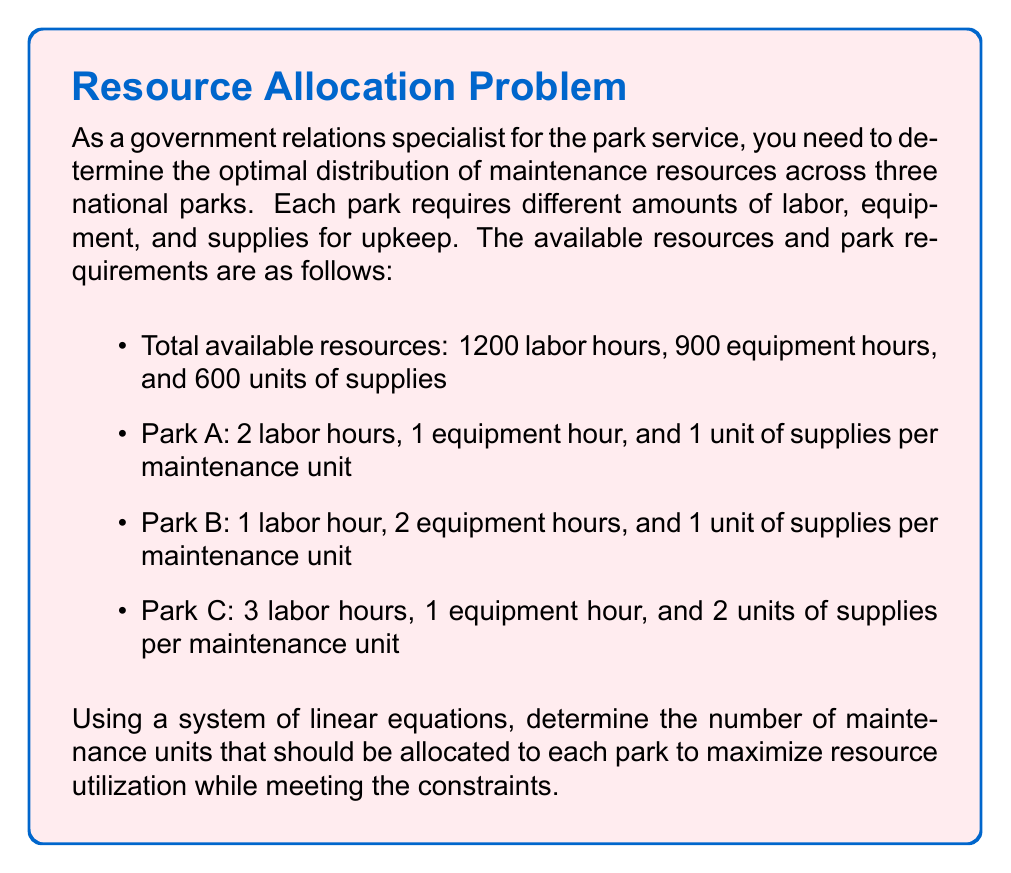Give your solution to this math problem. To solve this problem, we'll use a system of linear equations. Let's define our variables:

$x$ = number of maintenance units for Park A
$y$ = number of maintenance units for Park B
$z$ = number of maintenance units for Park C

Now, we can set up our system of equations based on the resource constraints:

1. Labor hours: $2x + y + 3z = 1200$
2. Equipment hours: $x + 2y + z = 900$
3. Supplies: $x + y + 2z = 600$

To solve this system, we'll use the elimination method:

Step 1: Multiply equation (1) by 2 and equation (2) by -3:
$4x + 2y + 6z = 2400$
$-3x - 6y - 3z = -2700$

Add these equations:
$x - 4y + 3z = -300$ (4)

Step 2: Multiply equation (2) by 2 and equation (3) by -1:
$2x + 4y + 2z = 1800$
$-x - y - 2z = -600$

Add these equations:
$x + 3y = 1200$ (5)

Step 3: Use equations (4) and (5) to solve for x and y in terms of z:
From (5): $x = 1200 - 3y$
Substitute into (4):
$(1200 - 3y) - 4y + 3z = -300$
$1200 - 7y + 3z = -300$
$-7y + 3z = -1500$
$y = \frac{1500 - 3z}{7}$

Step 4: Substitute these expressions into equation (3):
$(1200 - 3y) + (\frac{1500 - 3z}{7}) + 2z = 600$

Simplify and solve for z:
$1200 - 3(\frac{1500 - 3z}{7}) + \frac{1500 - 3z}{7} + 2z = 600$
$8400 - 4500 + 9z + 1500 - 3z + 14z = 4200$
$20z = -1200$
$z = -60$

Step 5: Calculate y and x:
$y = \frac{1500 - 3(-60)}{7} = \frac{1680}{7} = 240$
$x = 1200 - 3(240) = 480$

Step 6: Verify the solution satisfies all equations:
Labor: $2(480) + 240 + 3(-60) = 1200$
Equipment: $480 + 2(240) + (-60) = 900$
Supplies: $480 + 240 + 2(-60) = 600$

The solution satisfies all constraints.
Answer: Park A: 480 maintenance units
Park B: 240 maintenance units
Park C: 0 maintenance units (not feasible) 